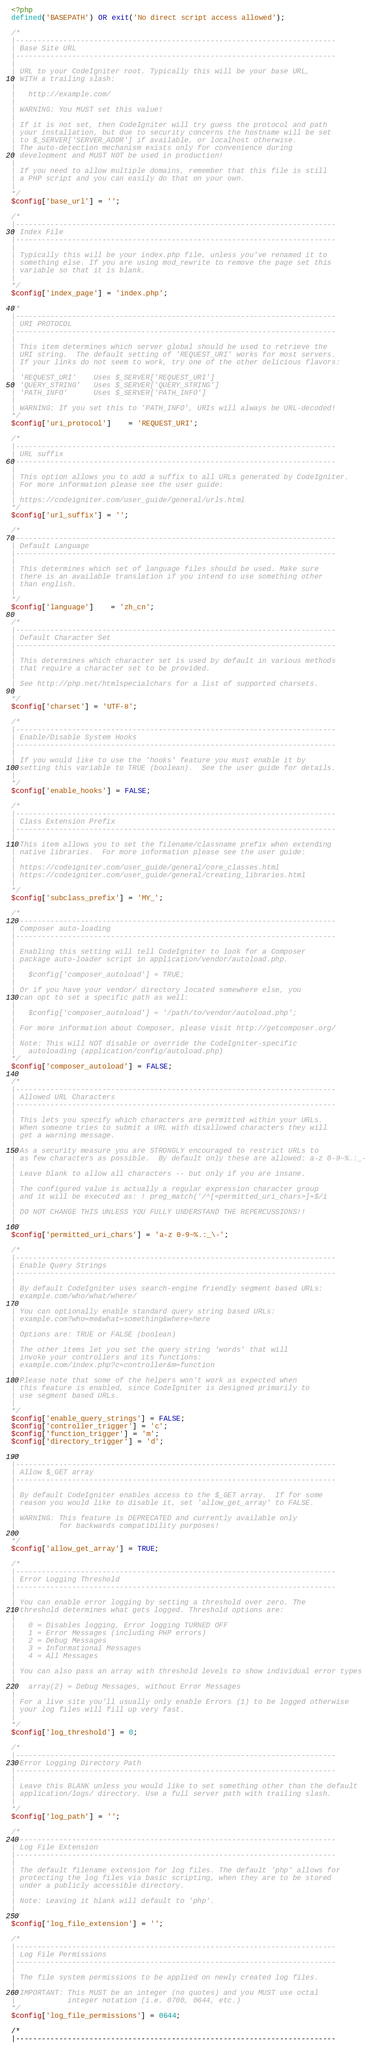Convert code to text. <code><loc_0><loc_0><loc_500><loc_500><_PHP_><?php
defined('BASEPATH') OR exit('No direct script access allowed');

/*
|--------------------------------------------------------------------------
| Base Site URL
|--------------------------------------------------------------------------
|
| URL to your CodeIgniter root. Typically this will be your base URL,
| WITH a trailing slash:
|
|	http://example.com/
|
| WARNING: You MUST set this value!
|
| If it is not set, then CodeIgniter will try guess the protocol and path
| your installation, but due to security concerns the hostname will be set
| to $_SERVER['SERVER_ADDR'] if available, or localhost otherwise.
| The auto-detection mechanism exists only for convenience during
| development and MUST NOT be used in production!
|
| If you need to allow multiple domains, remember that this file is still
| a PHP script and you can easily do that on your own.
|
*/
$config['base_url'] = '';

/*
|--------------------------------------------------------------------------
| Index File
|--------------------------------------------------------------------------
|
| Typically this will be your index.php file, unless you've renamed it to
| something else. If you are using mod_rewrite to remove the page set this
| variable so that it is blank.
|
*/
$config['index_page'] = 'index.php';

/*
|--------------------------------------------------------------------------
| URI PROTOCOL
|--------------------------------------------------------------------------
|
| This item determines which server global should be used to retrieve the
| URI string.  The default setting of 'REQUEST_URI' works for most servers.
| If your links do not seem to work, try one of the other delicious flavors:
|
| 'REQUEST_URI'    Uses $_SERVER['REQUEST_URI']
| 'QUERY_STRING'   Uses $_SERVER['QUERY_STRING']
| 'PATH_INFO'      Uses $_SERVER['PATH_INFO']
|
| WARNING: If you set this to 'PATH_INFO', URIs will always be URL-decoded!
*/
$config['uri_protocol']	= 'REQUEST_URI';

/*
|--------------------------------------------------------------------------
| URL suffix
|--------------------------------------------------------------------------
|
| This option allows you to add a suffix to all URLs generated by CodeIgniter.
| For more information please see the user guide:
|
| https://codeigniter.com/user_guide/general/urls.html
*/
$config['url_suffix'] = '';

/*
|--------------------------------------------------------------------------
| Default Language
|--------------------------------------------------------------------------
|
| This determines which set of language files should be used. Make sure
| there is an available translation if you intend to use something other
| than english.
|
*/
$config['language']	= 'zh_cn';

/*
|--------------------------------------------------------------------------
| Default Character Set
|--------------------------------------------------------------------------
|
| This determines which character set is used by default in various methods
| that require a character set to be provided.
|
| See http://php.net/htmlspecialchars for a list of supported charsets.
|
*/
$config['charset'] = 'UTF-8';

/*
|--------------------------------------------------------------------------
| Enable/Disable System Hooks
|--------------------------------------------------------------------------
|
| If you would like to use the 'hooks' feature you must enable it by
| setting this variable to TRUE (boolean).  See the user guide for details.
|
*/
$config['enable_hooks'] = FALSE;

/*
|--------------------------------------------------------------------------
| Class Extension Prefix
|--------------------------------------------------------------------------
|
| This item allows you to set the filename/classname prefix when extending
| native libraries.  For more information please see the user guide:
|
| https://codeigniter.com/user_guide/general/core_classes.html
| https://codeigniter.com/user_guide/general/creating_libraries.html
|
*/
$config['subclass_prefix'] = 'MY_';

/*
|--------------------------------------------------------------------------
| Composer auto-loading
|--------------------------------------------------------------------------
|
| Enabling this setting will tell CodeIgniter to look for a Composer
| package auto-loader script in application/vendor/autoload.php.
|
|	$config['composer_autoload'] = TRUE;
|
| Or if you have your vendor/ directory located somewhere else, you
| can opt to set a specific path as well:
|
|	$config['composer_autoload'] = '/path/to/vendor/autoload.php';
|
| For more information about Composer, please visit http://getcomposer.org/
|
| Note: This will NOT disable or override the CodeIgniter-specific
|	autoloading (application/config/autoload.php)
*/
$config['composer_autoload'] = FALSE;

/*
|--------------------------------------------------------------------------
| Allowed URL Characters
|--------------------------------------------------------------------------
|
| This lets you specify which characters are permitted within your URLs.
| When someone tries to submit a URL with disallowed characters they will
| get a warning message.
|
| As a security measure you are STRONGLY encouraged to restrict URLs to
| as few characters as possible.  By default only these are allowed: a-z 0-9~%.:_-
|
| Leave blank to allow all characters -- but only if you are insane.
|
| The configured value is actually a regular expression character group
| and it will be executed as: ! preg_match('/^[<permitted_uri_chars>]+$/i
|
| DO NOT CHANGE THIS UNLESS YOU FULLY UNDERSTAND THE REPERCUSSIONS!!
|
*/
$config['permitted_uri_chars'] = 'a-z 0-9~%.:_\-';

/*
|--------------------------------------------------------------------------
| Enable Query Strings
|--------------------------------------------------------------------------
|
| By default CodeIgniter uses search-engine friendly segment based URLs:
| example.com/who/what/where/
|
| You can optionally enable standard query string based URLs:
| example.com?who=me&what=something&where=here
|
| Options are: TRUE or FALSE (boolean)
|
| The other items let you set the query string 'words' that will
| invoke your controllers and its functions:
| example.com/index.php?c=controller&m=function
|
| Please note that some of the helpers won't work as expected when
| this feature is enabled, since CodeIgniter is designed primarily to
| use segment based URLs.
|
*/
$config['enable_query_strings'] = FALSE;
$config['controller_trigger'] = 'c';
$config['function_trigger'] = 'm';
$config['directory_trigger'] = 'd';

/*
|--------------------------------------------------------------------------
| Allow $_GET array
|--------------------------------------------------------------------------
|
| By default CodeIgniter enables access to the $_GET array.  If for some
| reason you would like to disable it, set 'allow_get_array' to FALSE.
|
| WARNING: This feature is DEPRECATED and currently available only
|          for backwards compatibility purposes!
|
*/
$config['allow_get_array'] = TRUE;

/*
|--------------------------------------------------------------------------
| Error Logging Threshold
|--------------------------------------------------------------------------
|
| You can enable error logging by setting a threshold over zero. The
| threshold determines what gets logged. Threshold options are:
|
|	0 = Disables logging, Error logging TURNED OFF
|	1 = Error Messages (including PHP errors)
|	2 = Debug Messages
|	3 = Informational Messages
|	4 = All Messages
|
| You can also pass an array with threshold levels to show individual error types
|
| 	array(2) = Debug Messages, without Error Messages
|
| For a live site you'll usually only enable Errors (1) to be logged otherwise
| your log files will fill up very fast.
|
*/
$config['log_threshold'] = 0;

/*
|--------------------------------------------------------------------------
| Error Logging Directory Path
|--------------------------------------------------------------------------
|
| Leave this BLANK unless you would like to set something other than the default
| application/logs/ directory. Use a full server path with trailing slash.
|
*/
$config['log_path'] = '';

/*
|--------------------------------------------------------------------------
| Log File Extension
|--------------------------------------------------------------------------
|
| The default filename extension for log files. The default 'php' allows for
| protecting the log files via basic scripting, when they are to be stored
| under a publicly accessible directory.
|
| Note: Leaving it blank will default to 'php'.
|
*/
$config['log_file_extension'] = '';

/*
|--------------------------------------------------------------------------
| Log File Permissions
|--------------------------------------------------------------------------
|
| The file system permissions to be applied on newly created log files.
|
| IMPORTANT: This MUST be an integer (no quotes) and you MUST use octal
|            integer notation (i.e. 0700, 0644, etc.)
*/
$config['log_file_permissions'] = 0644;

/*
|--------------------------------------------------------------------------</code> 